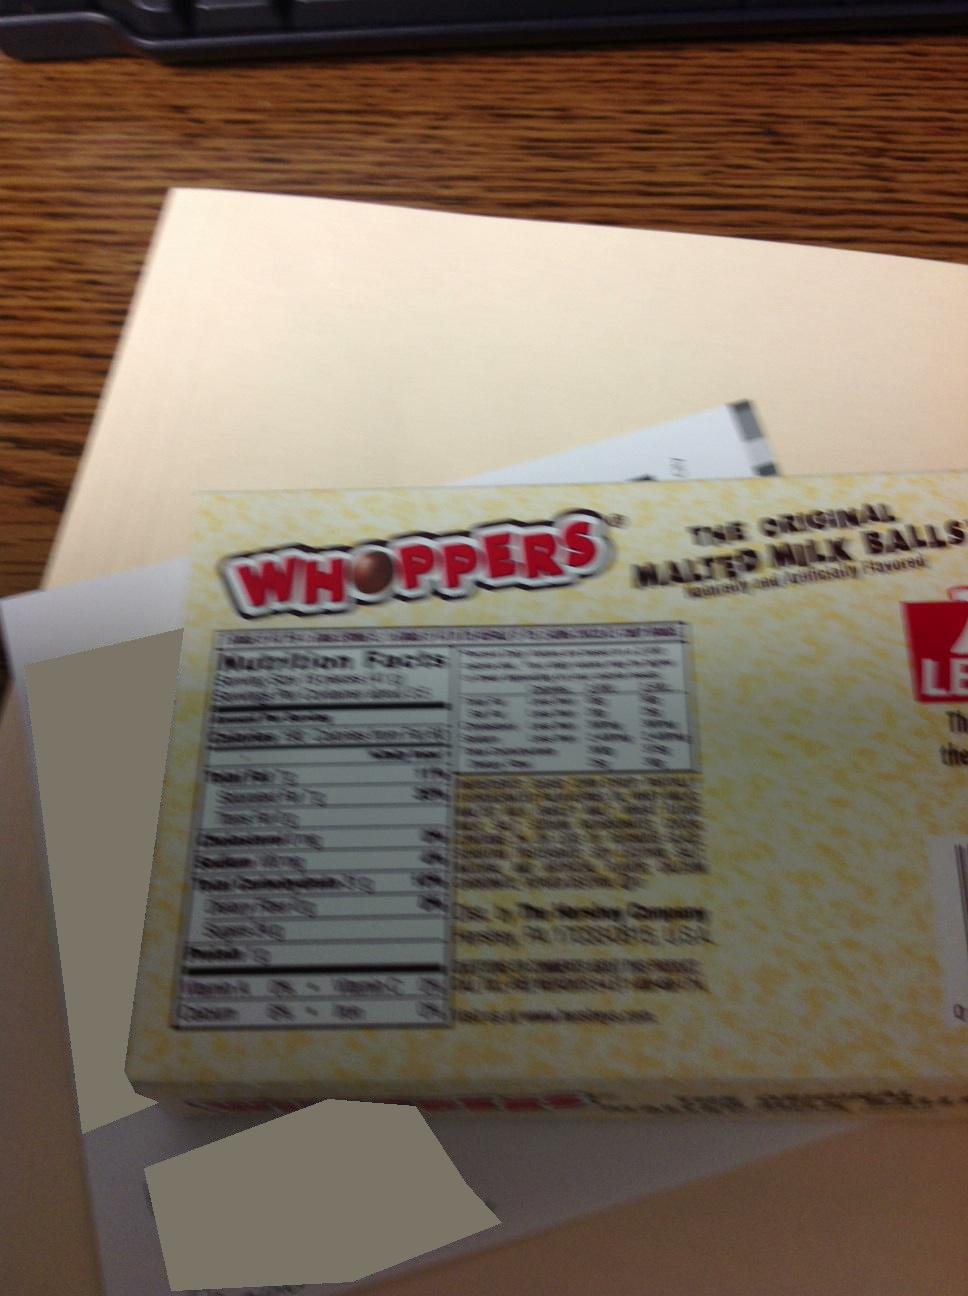What is the size of this box? The box in the image appears to be about 4-6 inches in height based on its proximity to standard desk items, though the exact dimensions cannot be precisely determined without additional context or clearer images. 